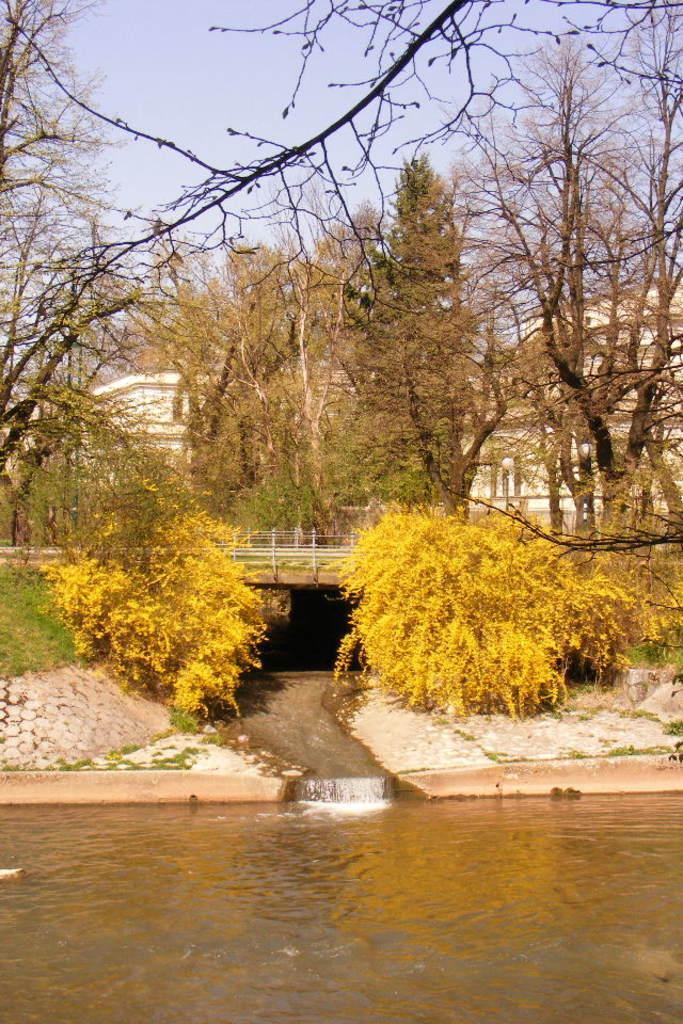Describe this image in one or two sentences. At the bottom of this image, there is water. In the background, there is a bridge on the water of a lake. In the background, there are trees, plants, buildings and grass on the ground and there are clouds in the sky. 